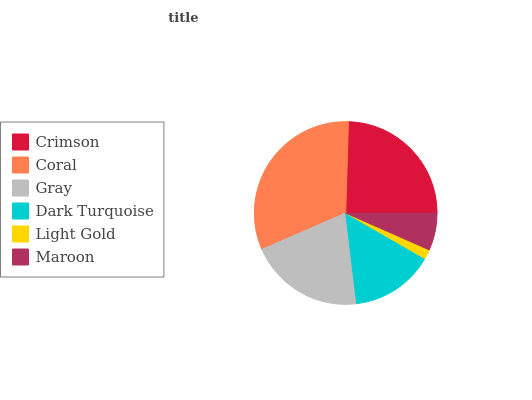Is Light Gold the minimum?
Answer yes or no. Yes. Is Coral the maximum?
Answer yes or no. Yes. Is Gray the minimum?
Answer yes or no. No. Is Gray the maximum?
Answer yes or no. No. Is Coral greater than Gray?
Answer yes or no. Yes. Is Gray less than Coral?
Answer yes or no. Yes. Is Gray greater than Coral?
Answer yes or no. No. Is Coral less than Gray?
Answer yes or no. No. Is Gray the high median?
Answer yes or no. Yes. Is Dark Turquoise the low median?
Answer yes or no. Yes. Is Light Gold the high median?
Answer yes or no. No. Is Crimson the low median?
Answer yes or no. No. 